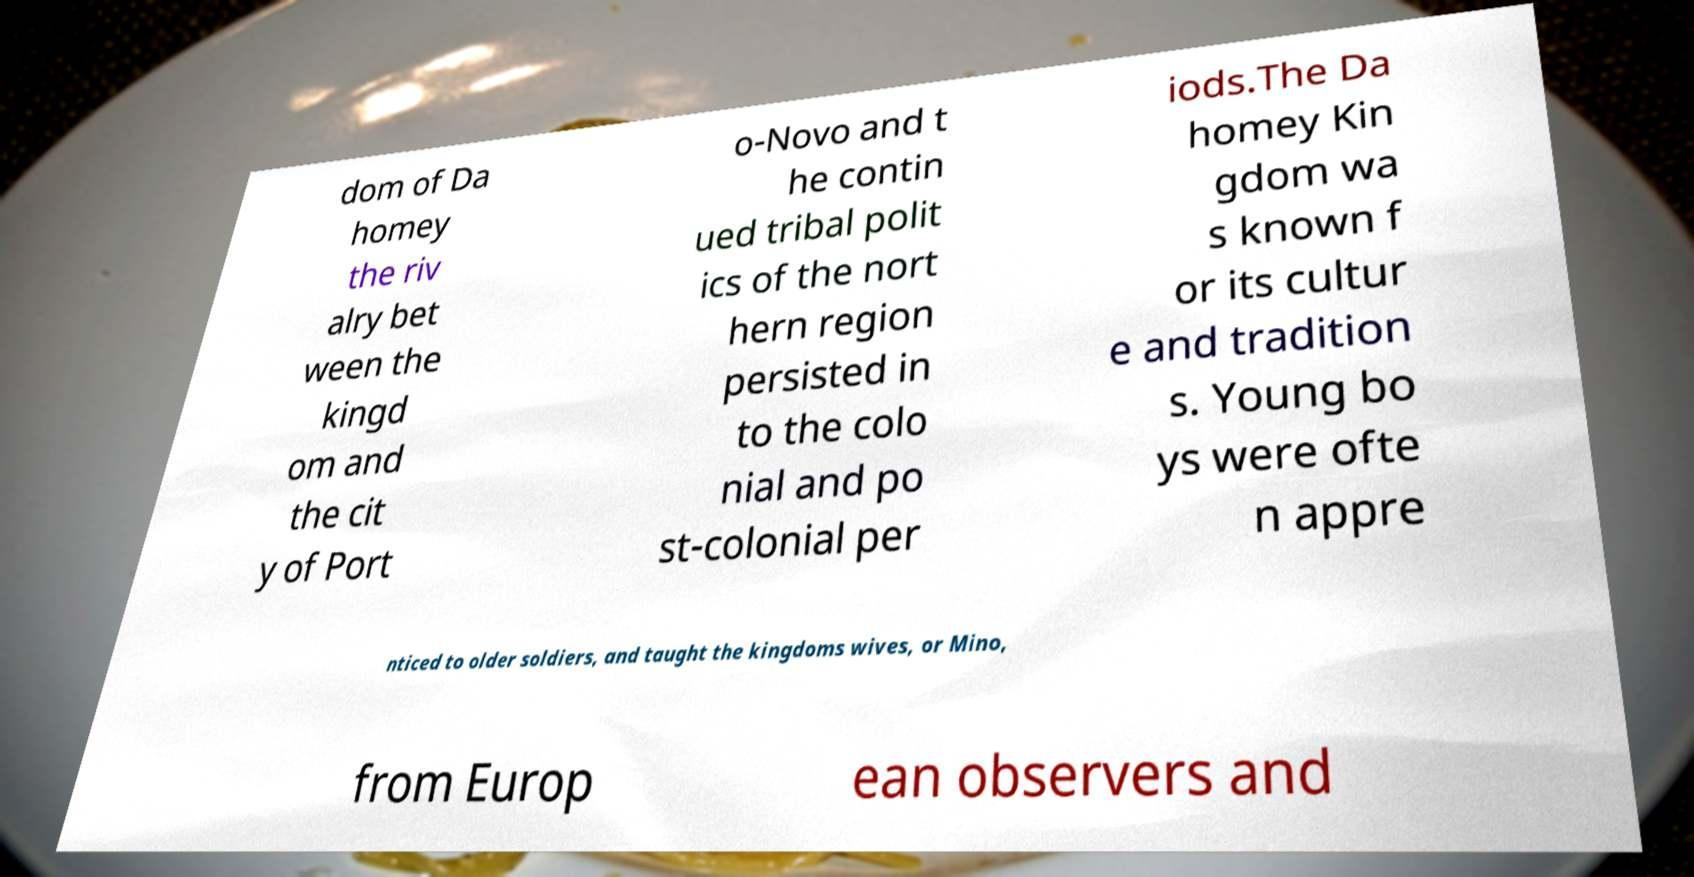Could you assist in decoding the text presented in this image and type it out clearly? dom of Da homey the riv alry bet ween the kingd om and the cit y of Port o-Novo and t he contin ued tribal polit ics of the nort hern region persisted in to the colo nial and po st-colonial per iods.The Da homey Kin gdom wa s known f or its cultur e and tradition s. Young bo ys were ofte n appre nticed to older soldiers, and taught the kingdoms wives, or Mino, from Europ ean observers and 